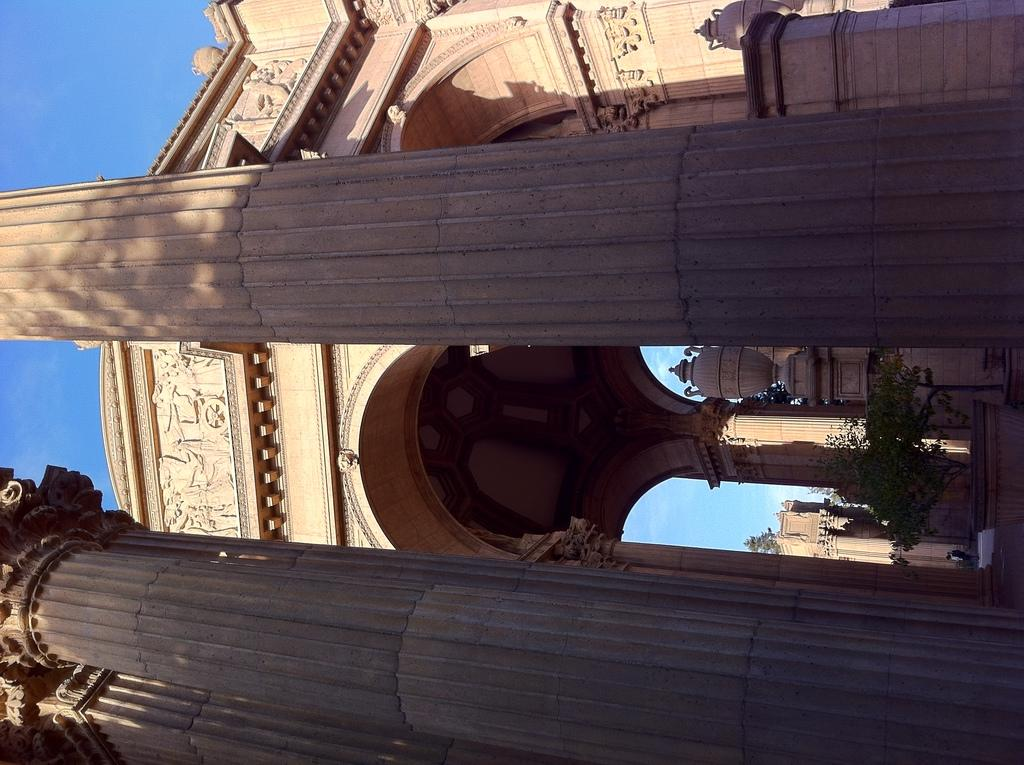What architectural features can be seen in the image? There are pillars and arches in the image. Can you describe the arches in more detail? The arches have a carved boundary at the top. What other elements are present in the image? There are trees in the image. What type of celery can be seen growing near the pillars in the image? There is no celery present in the image; it features pillars, arches, and trees. Who is the creator of the arches in the image? The image does not provide information about the creator of the arches. 